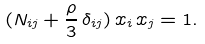<formula> <loc_0><loc_0><loc_500><loc_500>( N _ { i j } + \frac { \rho } { 3 } \, \delta _ { i j } ) \, x _ { i } \, x _ { j } = 1 .</formula> 